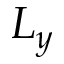<formula> <loc_0><loc_0><loc_500><loc_500>L _ { y }</formula> 